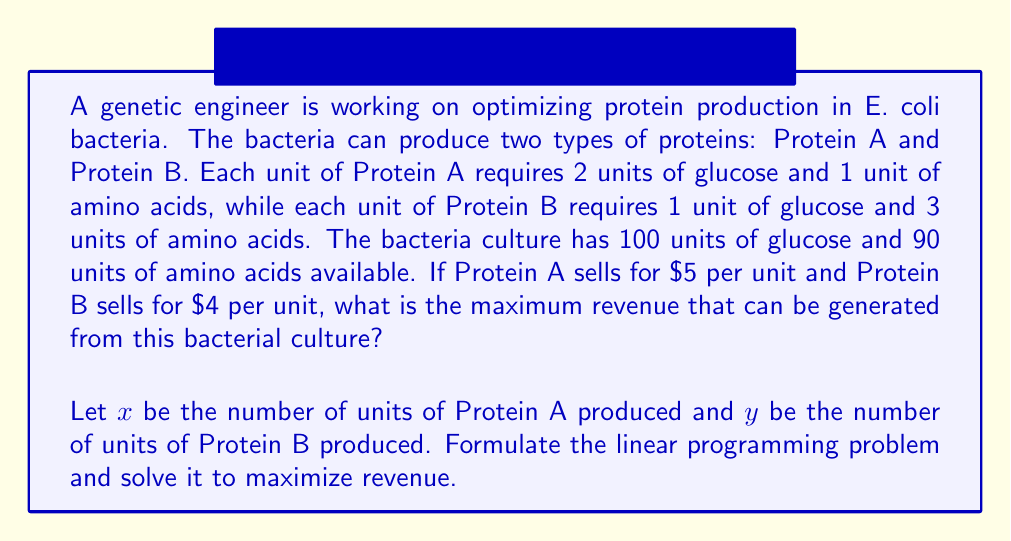Solve this math problem. To solve this optimization problem, we'll follow these steps:

1. Formulate the objective function and constraints:
   Objective function (maximize revenue): $Z = 5x + 4y$
   
   Constraints:
   Glucose: $2x + y \leq 100$
   Amino acids: $x + 3y \leq 90$
   Non-negativity: $x \geq 0, y \geq 0$

2. Graph the feasible region:
   We'll plot the constraints on a coordinate system.

[asy]
import geometry;

size(200);
real xmax = 70;
real ymax = 70;

// Axes
draw((0,0)--(xmax,0), arrow=Arrow(TeXHead));
draw((0,0)--(0,ymax), arrow=Arrow(TeXHead));

// Labels
label("x", (xmax,0), SE);
label("y", (0,ymax), NW);

// Constraints
draw((0,90)--(90,0), blue);
draw((0,100)--(50,0), red);

// Feasible region
fill((0,0)--(50,0)--(50,40)--(30,60)--(0,30)--cycle, palegreen+opacity(0.2));

// Points of interest
dot((0,30));
dot((50,0));
dot((50,40));
dot((30,60));

label("(0,30)", (0,30), W);
label("(50,0)", (50,0), S);
label("(50,40)", (50,40), E);
label("(30,60)", (30,60), NE);

label("2x + y = 100", (60,40), E, red);
label("x + 3y = 90", (60,30), E, blue);
[/asy]

3. Identify the corner points of the feasible region:
   (0, 0), (50, 0), (50, 40), (30, 60), (0, 30)

4. Evaluate the objective function at each corner point:
   $Z(0, 0) = 0$
   $Z(50, 0) = 5(50) + 4(0) = 250$
   $Z(50, 40) = 5(50) + 4(40) = 410$
   $Z(30, 60) = 5(30) + 4(60) = 390$
   $Z(0, 30) = 5(0) + 4(30) = 120$

5. Identify the maximum value:
   The maximum value occurs at the point (50, 40), yielding a revenue of $410.

Therefore, to maximize revenue, the genetic engineer should produce 50 units of Protein A and 40 units of Protein B.
Answer: The maximum revenue that can be generated is $410, achieved by producing 50 units of Protein A and 40 units of Protein B. 